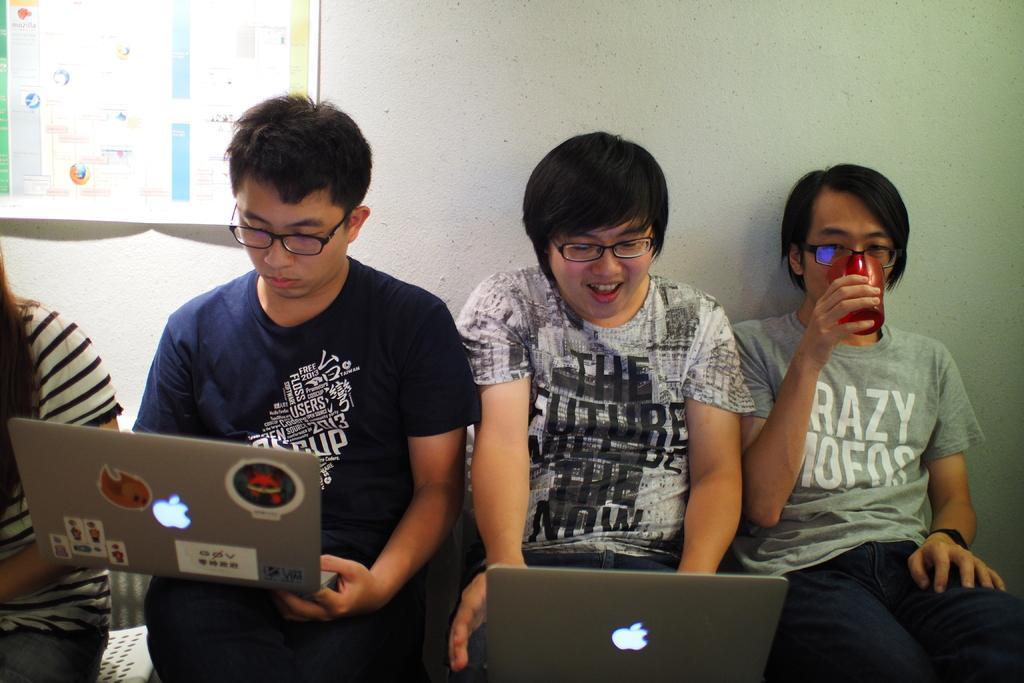How many people are in the image? There are two persons in the image. What are the persons holding in the image? Both persons are holding laptops. Can you describe any additional actions or activities of the persons? One person is drinking something. What else can be seen in the image besides the persons and laptops? There is a paper visible in the image. What type of chess game is being played by the persons in the image? There is no chess game present in the image; the persons are holding laptops and one is drinking something. Can you describe the locket worn by one of the persons in the image? There is no locket visible in the image; the persons are holding laptops and one is drinking something. 